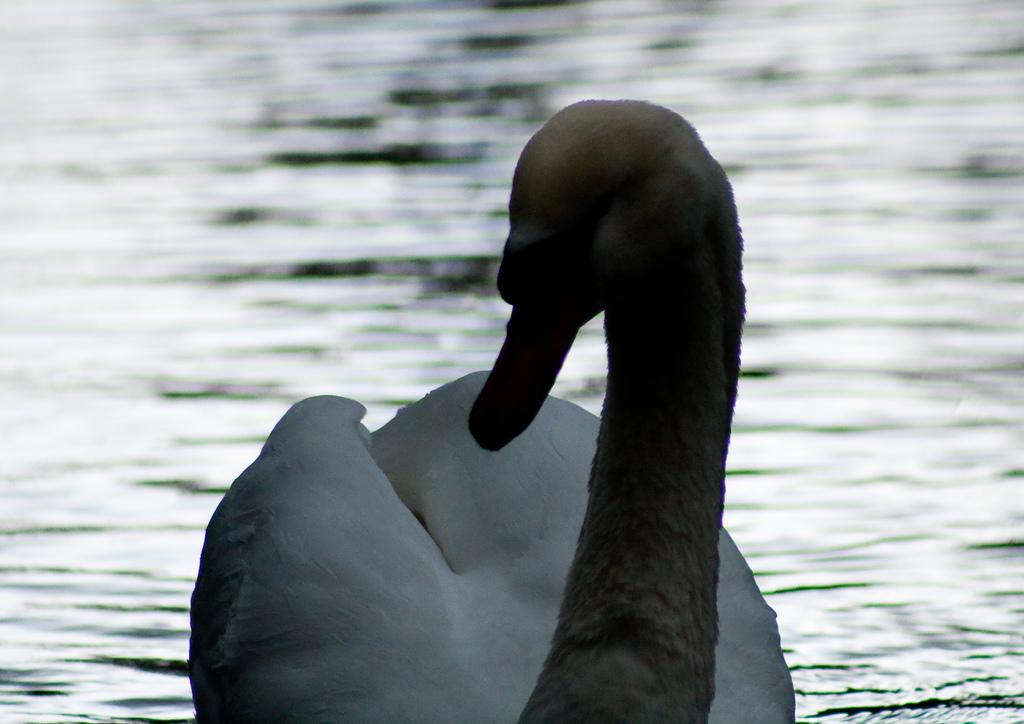What type of animal can be seen in the image? There is a bird in the image. What is the primary element in which the bird is situated? There is water visible in the image, and the bird is situated in it. What type of snake can be seen in the image? There is no snake present in the image; it features a bird in water. How many writers are visible in the image? There are no writers present in the image; it features a bird in water. 